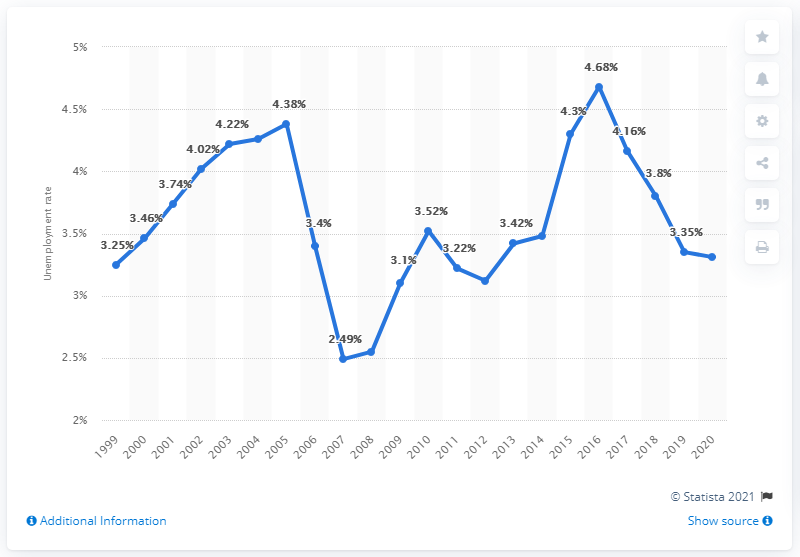What was the lowest unemployment rate depicted in the graph, and in which year did it occur? The lowest unemployment rate shown on the graph was 2.49% in the year 2008. This period may correlate with strong economic performance in Norway preceding the global financial crisis that occurred later that year. 